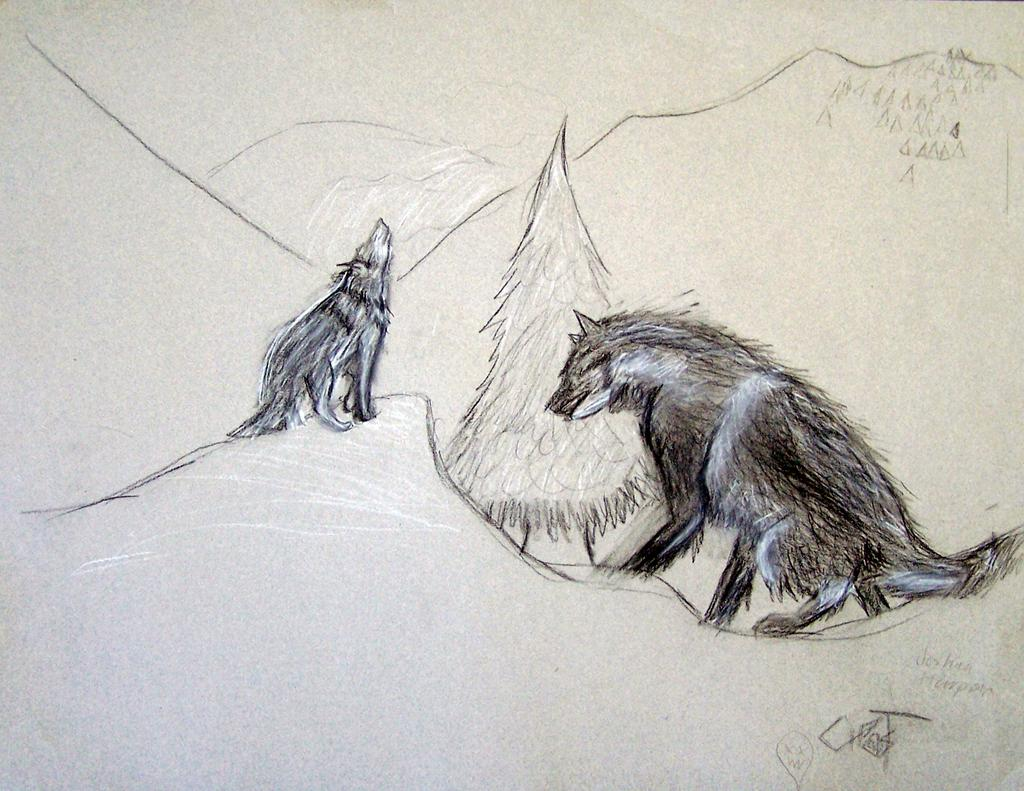What is the main subject of the paper in the image? The paper contains a sketch. What does the sketch depict? The sketch depicts two animals and a tree. What type of wind can be seen in the image? There is no wind present in the image. The image only features a paper with a sketch on it, depicting two animals and a tree. 